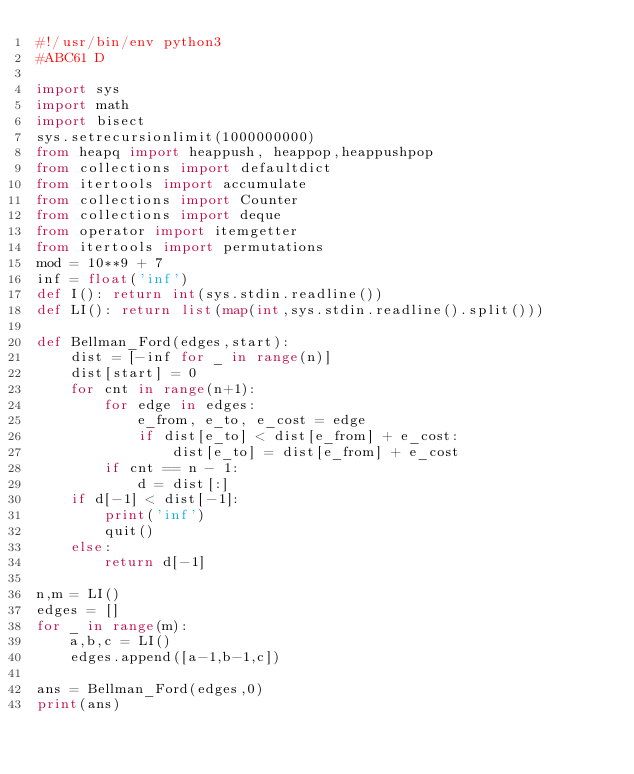Convert code to text. <code><loc_0><loc_0><loc_500><loc_500><_Python_>#!/usr/bin/env python3
#ABC61 D

import sys
import math
import bisect
sys.setrecursionlimit(1000000000)
from heapq import heappush, heappop,heappushpop
from collections import defaultdict
from itertools import accumulate
from collections import Counter
from collections import deque
from operator import itemgetter
from itertools import permutations
mod = 10**9 + 7
inf = float('inf')
def I(): return int(sys.stdin.readline())
def LI(): return list(map(int,sys.stdin.readline().split()))

def Bellman_Ford(edges,start):
    dist = [-inf for _ in range(n)]
    dist[start] = 0
    for cnt in range(n+1):
        for edge in edges:
            e_from, e_to, e_cost = edge
            if dist[e_to] < dist[e_from] + e_cost:
                dist[e_to] = dist[e_from] + e_cost
        if cnt == n - 1:
            d = dist[:]
    if d[-1] < dist[-1]:
        print('inf')
        quit()
    else:
        return d[-1]

n,m = LI()
edges = []
for _ in range(m):
    a,b,c = LI()
    edges.append([a-1,b-1,c])

ans = Bellman_Ford(edges,0)
print(ans)
</code> 